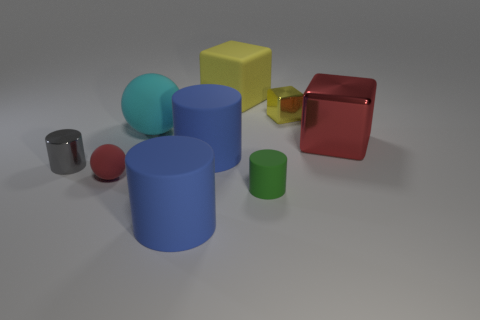How many cubes are both right of the small green matte thing and behind the cyan rubber ball? Upon examining the elements in the image, there is one cube that is placed both to the right of the small green matte object and behind the cyan rubber ball. It's important to consider the spatial relationships from the viewer's perspective. 